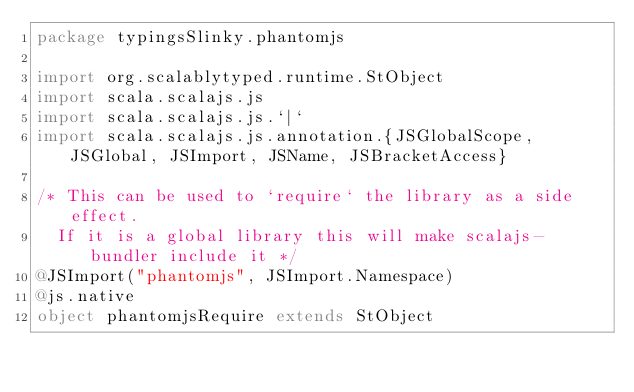<code> <loc_0><loc_0><loc_500><loc_500><_Scala_>package typingsSlinky.phantomjs

import org.scalablytyped.runtime.StObject
import scala.scalajs.js
import scala.scalajs.js.`|`
import scala.scalajs.js.annotation.{JSGlobalScope, JSGlobal, JSImport, JSName, JSBracketAccess}

/* This can be used to `require` the library as a side effect.
  If it is a global library this will make scalajs-bundler include it */
@JSImport("phantomjs", JSImport.Namespace)
@js.native
object phantomjsRequire extends StObject
</code> 